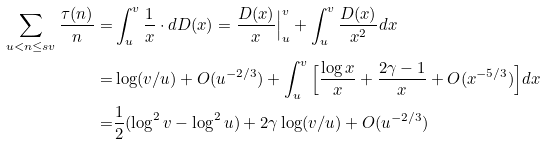Convert formula to latex. <formula><loc_0><loc_0><loc_500><loc_500>\sum _ { u < n \leq s v } \frac { \tau ( n ) } { n } = & \int _ { u } ^ { v } \frac { 1 } { x } \cdot d D ( x ) = \frac { D ( x ) } { x } \Big | _ { u } ^ { v } + \int _ { u } ^ { v } \frac { D ( x ) } { x ^ { 2 } } d x \\ = & \log ( v / u ) + O ( u ^ { - 2 / 3 } ) + \int _ { u } ^ { v } \Big [ \frac { \log x } { x } + \frac { 2 \gamma - 1 } { x } + O ( x ^ { - 5 / 3 } ) \Big ] d x \\ = & \frac { 1 } { 2 } ( \log ^ { 2 } v - \log ^ { 2 } u ) + 2 \gamma \log ( v / u ) + O ( u ^ { - 2 / 3 } )</formula> 